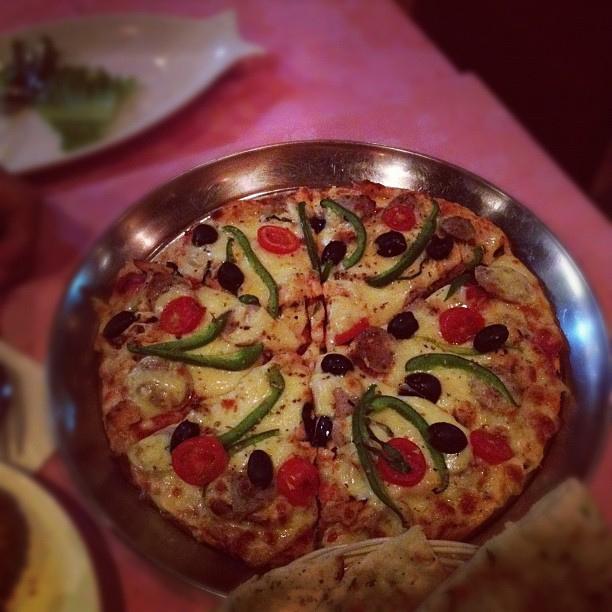What is the green on the pizza?
Concise answer only. Peppers. Is this an egg pizza?
Concise answer only. No. What is the green vegetable in the pan?
Give a very brief answer. Green pepper. Is pizza a "finger" food?
Answer briefly. Yes. What is the pizza sitting on?
Quick response, please. Plate. What toppings are on the pizza?
Quick response, please. Pepper. Is this pizza?
Give a very brief answer. Yes. What vegetables are on the pizza?
Give a very brief answer. Peppers. 